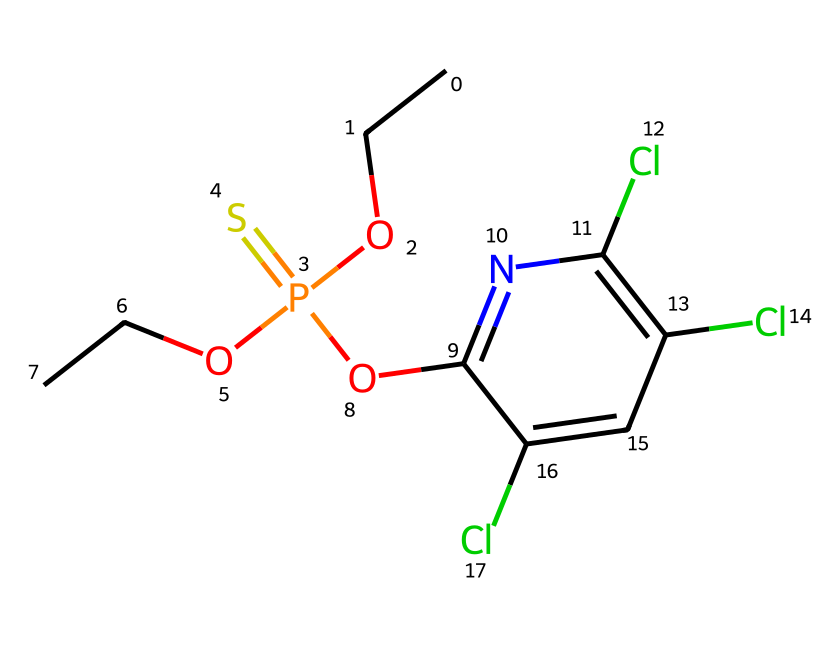What is the main functional group in this compound? The compound contains a phosphorus atom bonded to oxygen atoms, indicating that the functional group is a phosphate. The presence of a double bond to sulfur (thio) and the overall structure specifically point to it being a phosphorothioate.
Answer: phosphorothioate How many chlorine atoms are present in this molecule? By analyzing the structure, we see three chlorine (Cl) atoms directly attached to the aromatic ring. These are counted visually on the structure.
Answer: three What is the total number of carbon atoms in this compound? By counting the carbon atoms in the SMILES representation, we identify five from the alkyl chains (two ethyl groups) and four from the ring structure, summing up to a total of nine carbons.
Answer: nine Can this compound act as an insecticide? This compound is an organophosphate, which are commonly known to have insecticidal properties due to their neurotoxic effects on pests, which suggests it can act as an insecticide.
Answer: yes What does the "O" at the end of the SMILES represent? The "O" at the end signifies that there is a hydroxy or alkoxy group, indicating the presence of an ether or alcohol functional group, which is important for its reactivity and interactions.
Answer: ether What is the oxidation state of phosphorus in this molecule? In this structure, phosphorus is bonded to three oxygens and one sulfur, representing an oxidation state of +5, typically indicating it can behave as an electrophile in organophosphate reactions.
Answer: plus five 